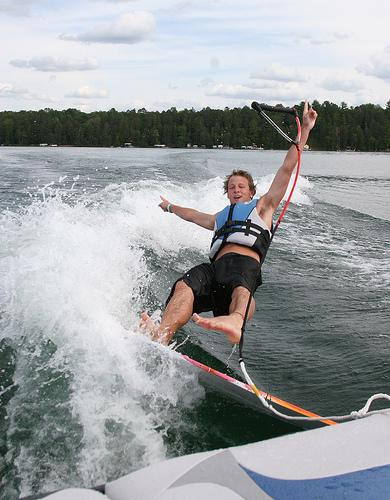Talk about the background of the image and what it adds to the scene. There is a line of dark green trees in the background, enhancing the outdoor setting of the man waterboarding on a beautiful day. Mention the key elements seen in the image and the overall situation. The image shows a man waterboarding in the air, wearing a life jacket and black shorts, holding a ski rope, with trees in the background and water below. Describe the clothing and accessories of the person in the image. The man in the image is wearing a blue, grey, and white life jacket, black swimming shorts, and a blue bracelet on his wrist. In a poetic way, describe the man's experience in the image. Amidst the splendid greenery and undulating waters, a daring man takes flight, his arms akimbo, his heart ablaze, defying gravity atop a vibrant wakeboard. What is the activity that the person in the image is doing, and what gear are they using? The man is waterboarding on a pink and orange skiing board while holding onto a ski rope attached to a boat, wearing a life jacket and black shorts. What is the condition of the equipment used by the person in the image? The equipment, including the skiing board, life jacket, and ski rope, appears to be in good condition and well-maintained, contributing to the man's waterboarding experience. Explain the position and expression of the person in the image. The man is in mid-air, falling off his ski board, his mouth open, with short hair, and his right hand and left foot visible in the air. Describe the water scene and any relevant details in the image. There is a wake from a boat in the water, splashes around the man's foot, the white rope above the water, and a tiny drop of water in the air. Mention any challenges the person in the image might be facing during this activity. The man is struggling to maintain his balance on the ski board due to a foot in the air and has let go of the tow ropes while his mouth is open in surprise. Write a lighthearted description of the man and his activity in the image. A spirited man with hairy legs is having the time of his life as he rides a colorful wakeboard behind a boat, soaring through the air and letting go of the tow ropes. 